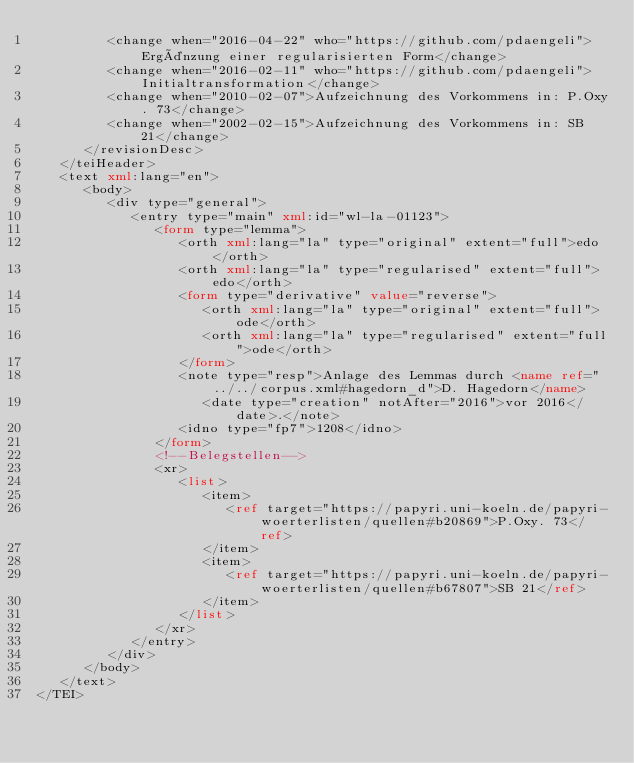<code> <loc_0><loc_0><loc_500><loc_500><_XML_>         <change when="2016-04-22" who="https://github.com/pdaengeli">Ergänzung einer regularisierten Form</change>
         <change when="2016-02-11" who="https://github.com/pdaengeli">Initialtransformation</change>
         <change when="2010-02-07">Aufzeichnung des Vorkommens in: P.Oxy. 73</change>
         <change when="2002-02-15">Aufzeichnung des Vorkommens in: SB 21</change>
      </revisionDesc>
   </teiHeader>
   <text xml:lang="en">
      <body>
         <div type="general">
            <entry type="main" xml:id="wl-la-01123">
               <form type="lemma">
                  <orth xml:lang="la" type="original" extent="full">edo</orth>
                  <orth xml:lang="la" type="regularised" extent="full">edo</orth>
                  <form type="derivative" value="reverse">
                     <orth xml:lang="la" type="original" extent="full">ode</orth>
                     <orth xml:lang="la" type="regularised" extent="full">ode</orth>
                  </form>
                  <note type="resp">Anlage des Lemmas durch <name ref="../../corpus.xml#hagedorn_d">D. Hagedorn</name>
                     <date type="creation" notAfter="2016">vor 2016</date>.</note>
                  <idno type="fp7">1208</idno>
               </form>
               <!--Belegstellen-->
               <xr>
                  <list>
                     <item>
                        <ref target="https://papyri.uni-koeln.de/papyri-woerterlisten/quellen#b20869">P.Oxy. 73</ref>
                     </item>
                     <item>
                        <ref target="https://papyri.uni-koeln.de/papyri-woerterlisten/quellen#b67807">SB 21</ref>
                     </item>
                  </list>
               </xr>
            </entry>
         </div>
      </body>
   </text>
</TEI>
</code> 